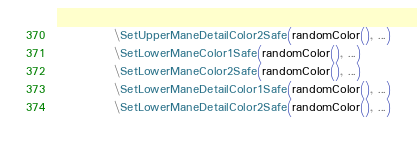Convert code to text. <code><loc_0><loc_0><loc_500><loc_500><_MoonScript_>			\SetUpperManeDetailColor2Safe(randomColor(), ...)
			\SetLowerManeColor1Safe(randomColor(), ...)
			\SetLowerManeColor2Safe(randomColor(), ...)
			\SetLowerManeDetailColor1Safe(randomColor(), ...)
			\SetLowerManeDetailColor2Safe(randomColor(), ...)</code> 